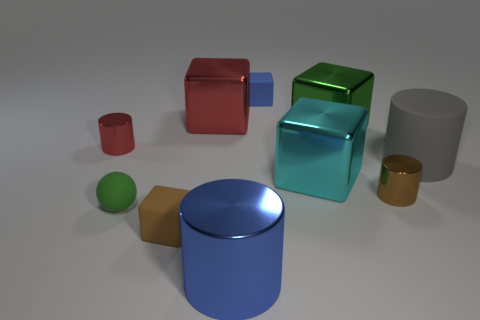What shape is the gray thing?
Keep it short and to the point. Cylinder. The rubber object that is on the right side of the ball and on the left side of the large red metal cube has what shape?
Offer a terse response. Cube. There is a big thing that is the same material as the green sphere; what color is it?
Your answer should be very brief. Gray. There is a large metal thing that is in front of the tiny cylinder in front of the shiny cube that is in front of the green metal cube; what is its shape?
Ensure brevity in your answer.  Cylinder. What is the size of the brown metal object?
Provide a succinct answer. Small. What shape is the small blue thing that is the same material as the gray object?
Offer a terse response. Cube. Are there fewer big cylinders that are in front of the gray rubber object than tiny red cylinders?
Make the answer very short. No. The large cube left of the blue cube is what color?
Provide a short and direct response. Red. There is a large cube that is the same color as the small rubber sphere; what is it made of?
Your answer should be compact. Metal. Are there any other large objects that have the same shape as the blue metallic thing?
Offer a very short reply. Yes. 